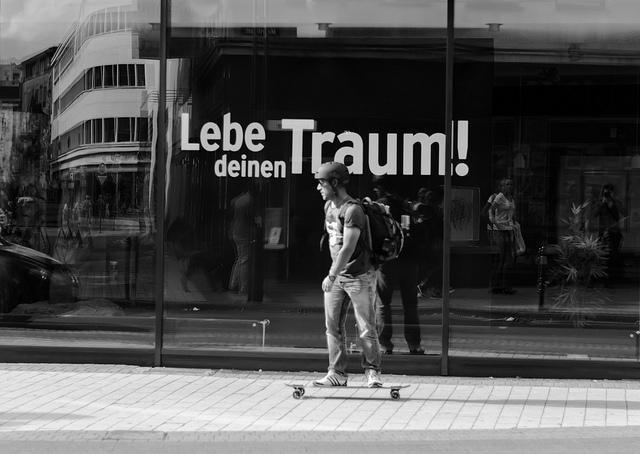What time of day is it likely to be?
Answer the question by selecting the correct answer among the 4 following choices.
Options: Morning, afternoon, night, evening. Afternoon. 